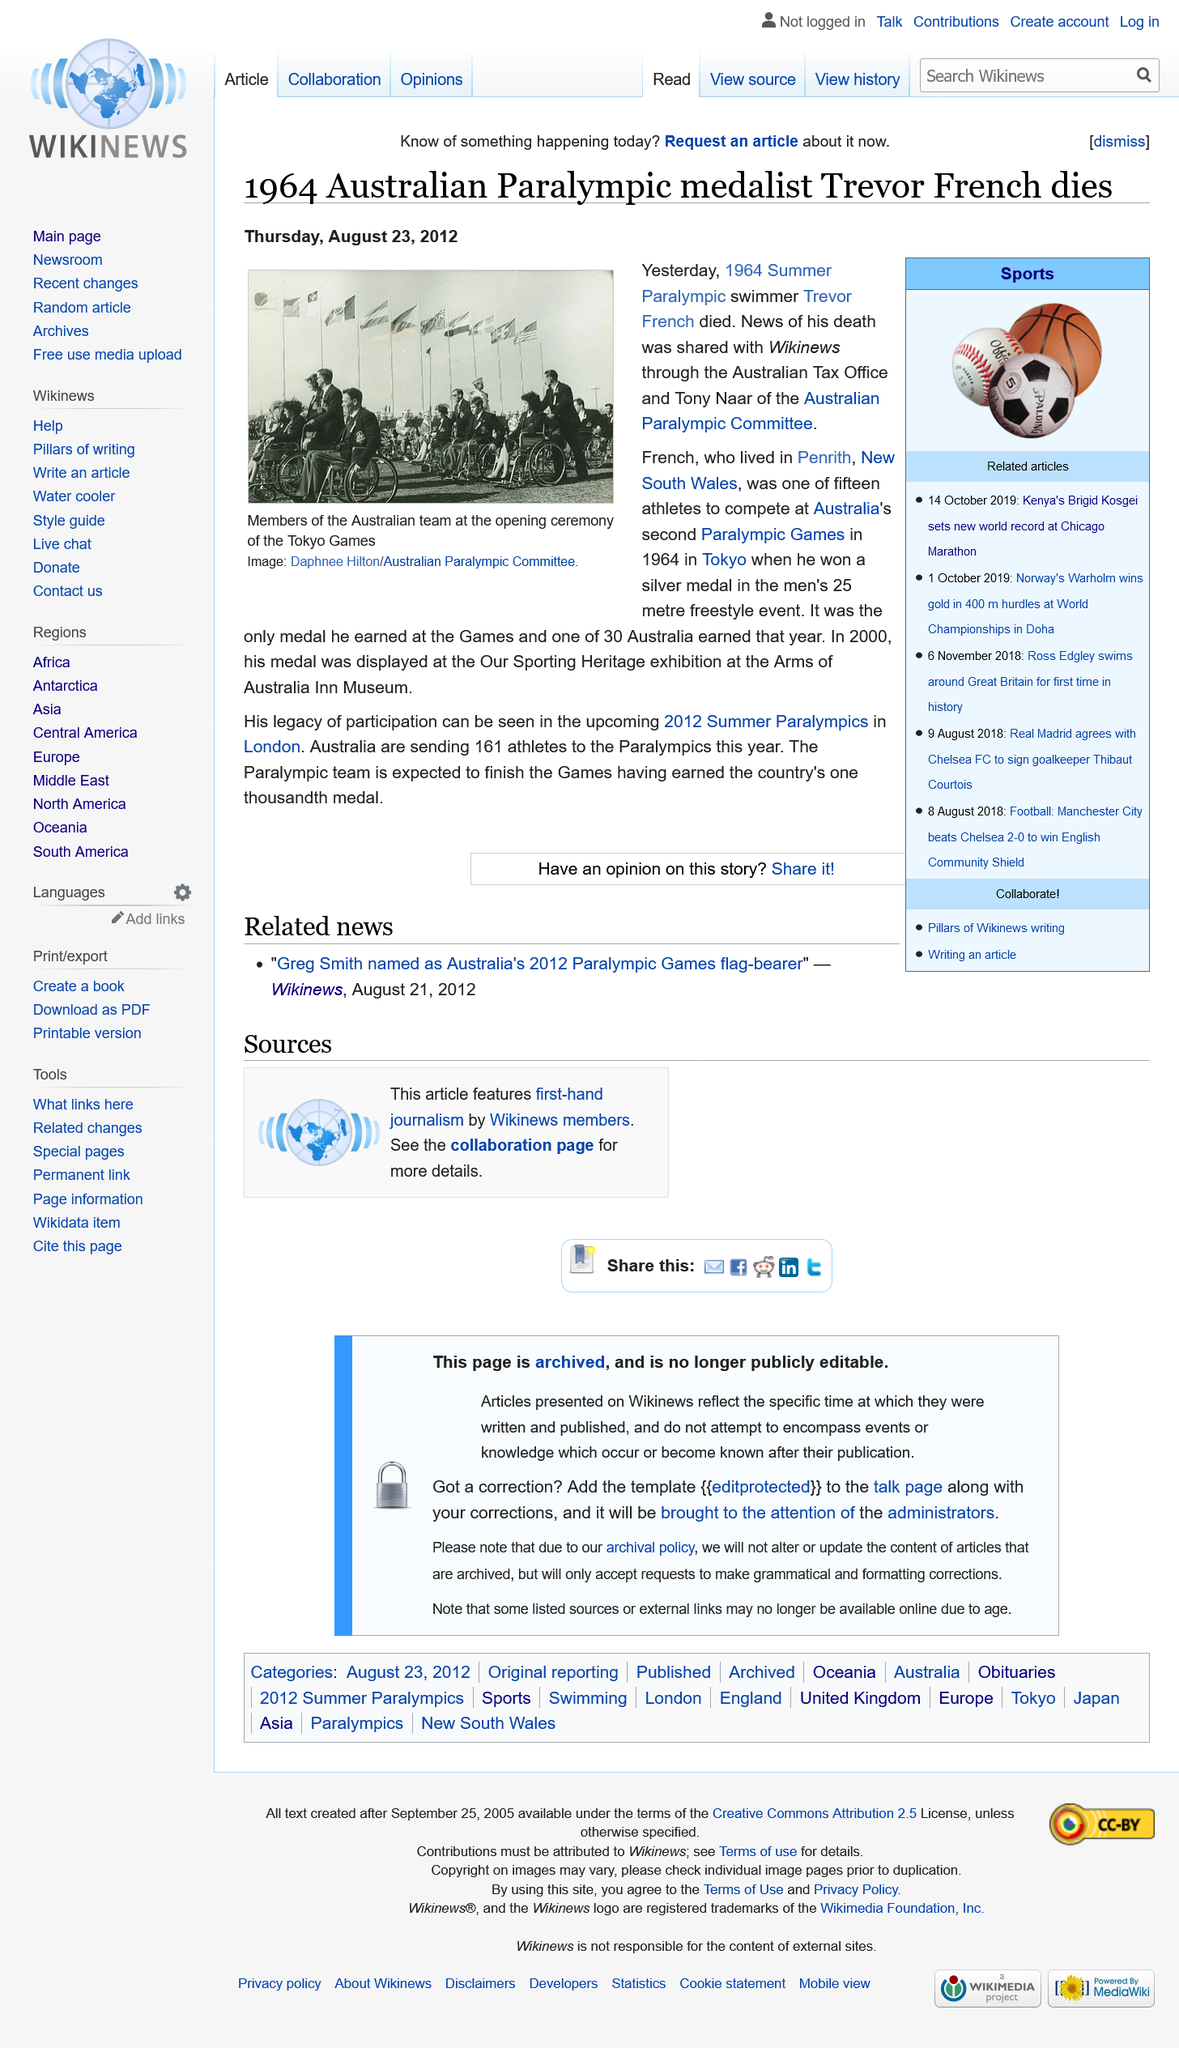List a handful of essential elements in this visual. Australia is sending 161 athletes to the 2012 Summer Paralympics in London. The deceased paralympic swimmer resided in Penrith, New South Wales, which is located in Australia. French athletes won a medal at the 1964 Paralympic Games held in Tokyo, Japan. 